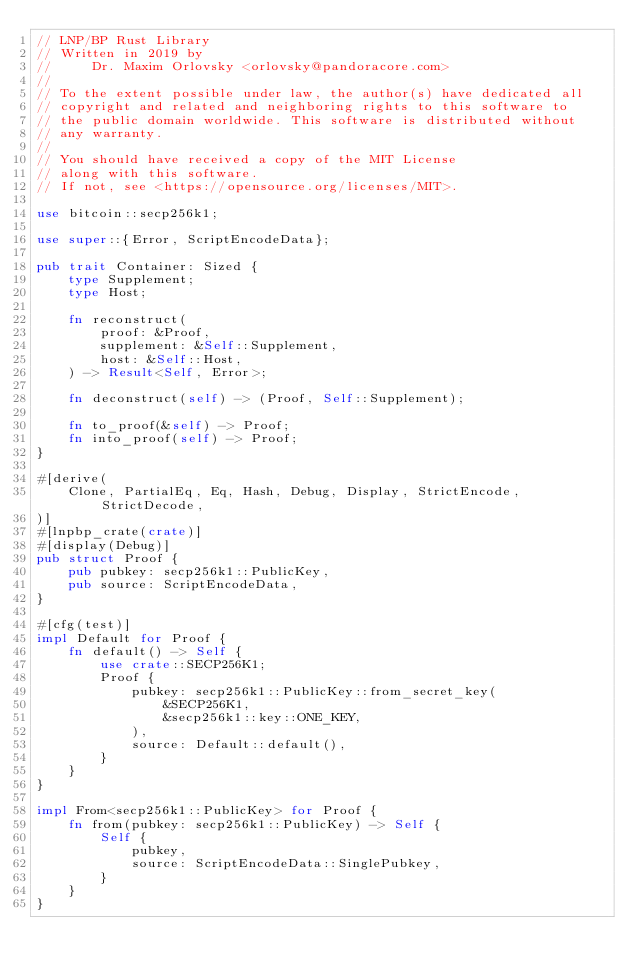<code> <loc_0><loc_0><loc_500><loc_500><_Rust_>// LNP/BP Rust Library
// Written in 2019 by
//     Dr. Maxim Orlovsky <orlovsky@pandoracore.com>
//
// To the extent possible under law, the author(s) have dedicated all
// copyright and related and neighboring rights to this software to
// the public domain worldwide. This software is distributed without
// any warranty.
//
// You should have received a copy of the MIT License
// along with this software.
// If not, see <https://opensource.org/licenses/MIT>.

use bitcoin::secp256k1;

use super::{Error, ScriptEncodeData};

pub trait Container: Sized {
    type Supplement;
    type Host;

    fn reconstruct(
        proof: &Proof,
        supplement: &Self::Supplement,
        host: &Self::Host,
    ) -> Result<Self, Error>;

    fn deconstruct(self) -> (Proof, Self::Supplement);

    fn to_proof(&self) -> Proof;
    fn into_proof(self) -> Proof;
}

#[derive(
    Clone, PartialEq, Eq, Hash, Debug, Display, StrictEncode, StrictDecode,
)]
#[lnpbp_crate(crate)]
#[display(Debug)]
pub struct Proof {
    pub pubkey: secp256k1::PublicKey,
    pub source: ScriptEncodeData,
}

#[cfg(test)]
impl Default for Proof {
    fn default() -> Self {
        use crate::SECP256K1;
        Proof {
            pubkey: secp256k1::PublicKey::from_secret_key(
                &SECP256K1,
                &secp256k1::key::ONE_KEY,
            ),
            source: Default::default(),
        }
    }
}

impl From<secp256k1::PublicKey> for Proof {
    fn from(pubkey: secp256k1::PublicKey) -> Self {
        Self {
            pubkey,
            source: ScriptEncodeData::SinglePubkey,
        }
    }
}
</code> 